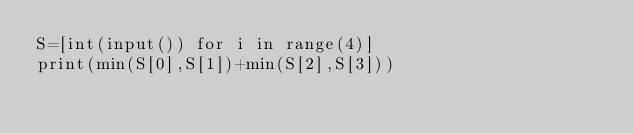Convert code to text. <code><loc_0><loc_0><loc_500><loc_500><_Python_>S=[int(input()) for i in range(4)]
print(min(S[0],S[1])+min(S[2],S[3]))</code> 